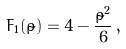Convert formula to latex. <formula><loc_0><loc_0><loc_500><loc_500>F _ { 1 } ( \tilde { \rho } ) = 4 - \frac { \tilde { \rho } ^ { 2 } } { 6 } \, ,</formula> 